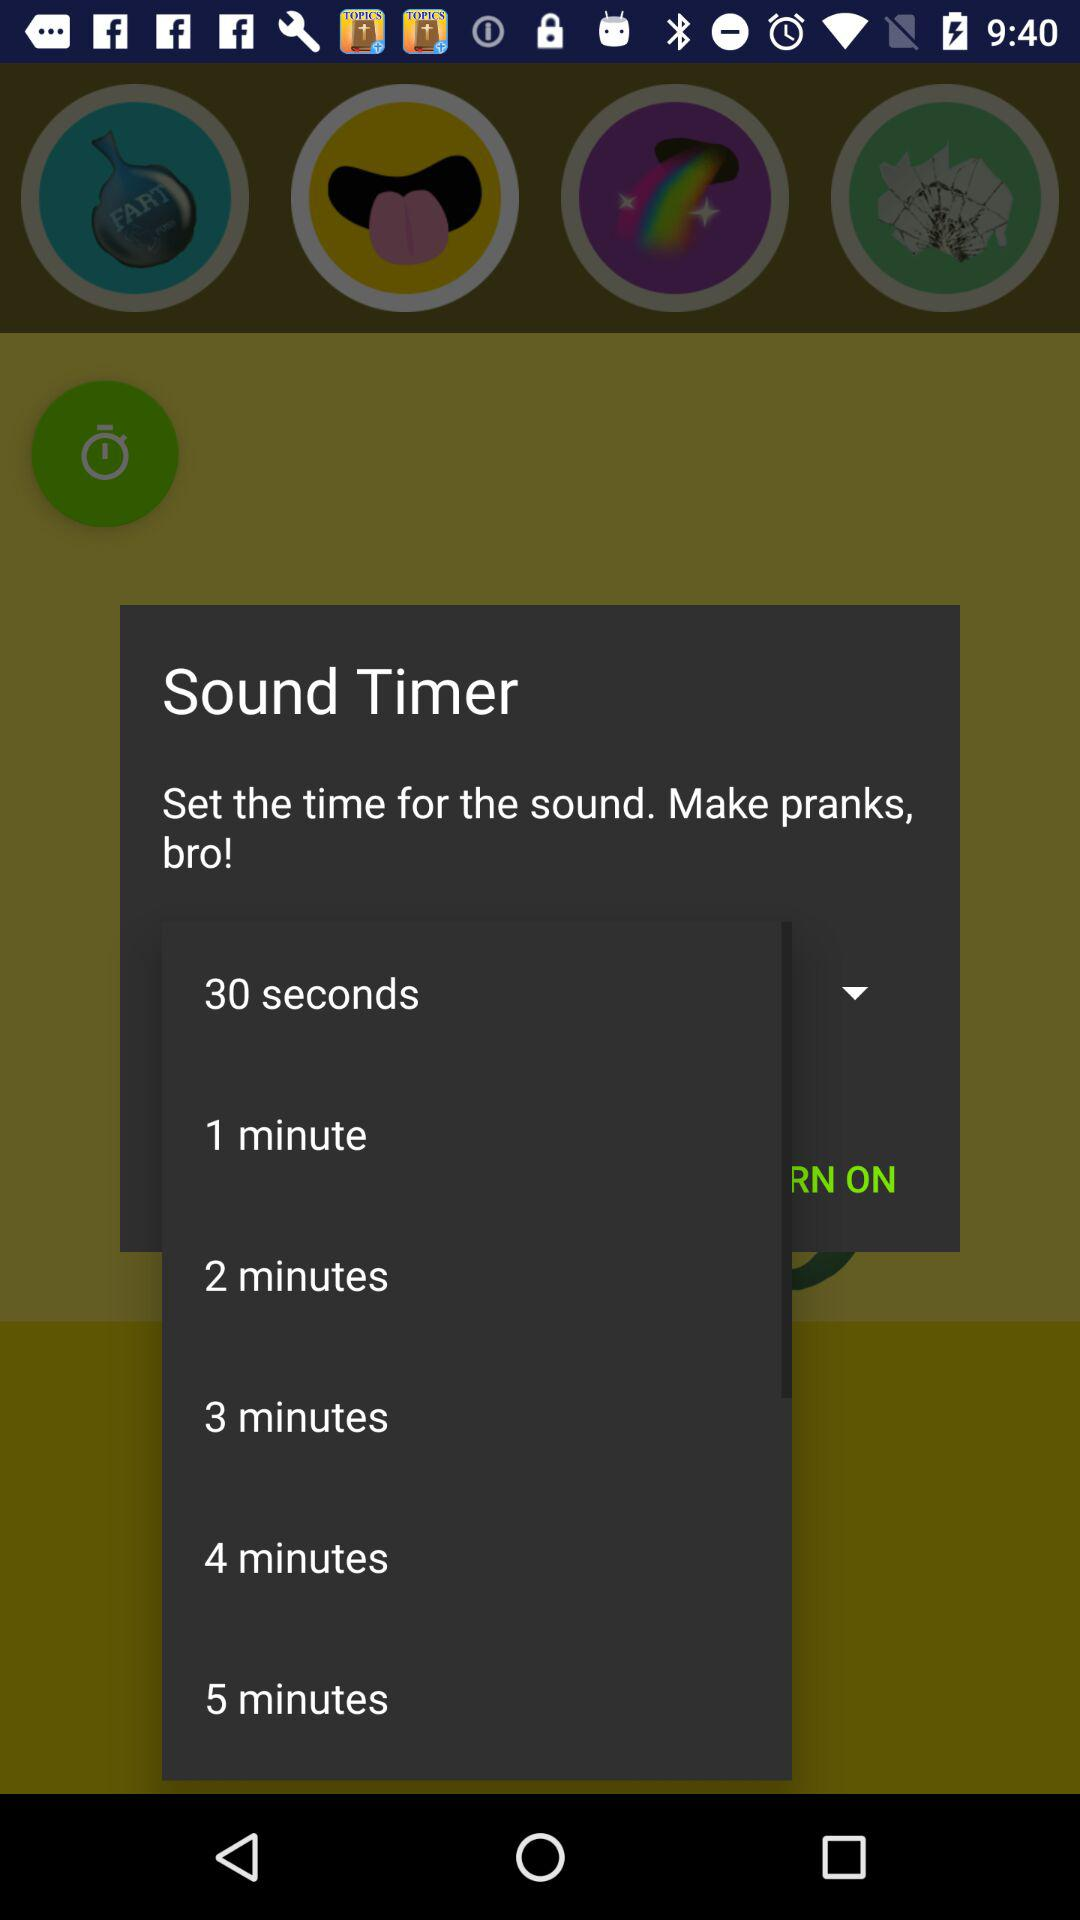How many minutes does the longest time option last?
Answer the question using a single word or phrase. 5 